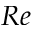<formula> <loc_0><loc_0><loc_500><loc_500>R e</formula> 